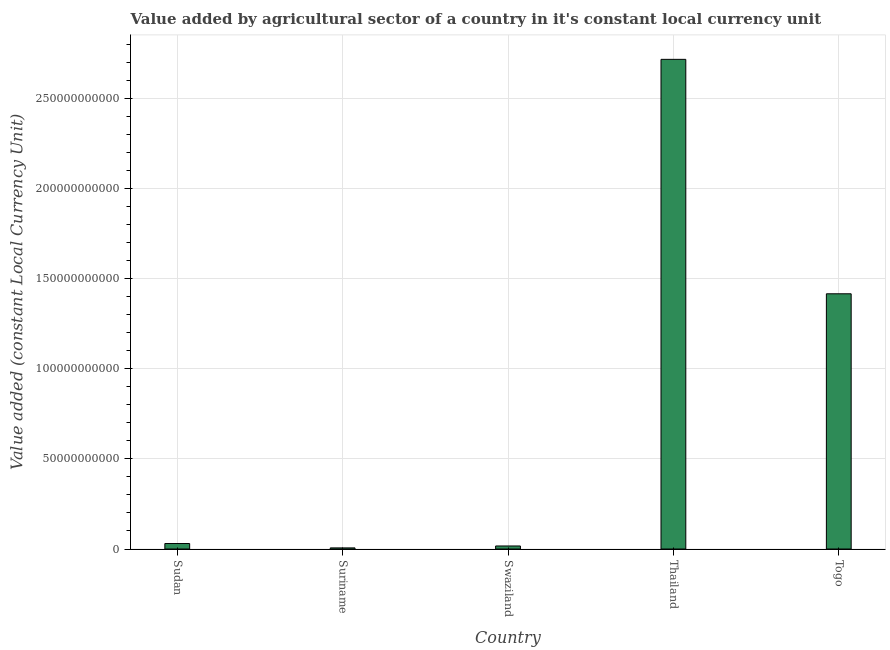Does the graph contain grids?
Give a very brief answer. Yes. What is the title of the graph?
Your answer should be compact. Value added by agricultural sector of a country in it's constant local currency unit. What is the label or title of the X-axis?
Give a very brief answer. Country. What is the label or title of the Y-axis?
Your response must be concise. Value added (constant Local Currency Unit). What is the value added by agriculture sector in Sudan?
Your response must be concise. 3.04e+09. Across all countries, what is the maximum value added by agriculture sector?
Your answer should be compact. 2.72e+11. Across all countries, what is the minimum value added by agriculture sector?
Your answer should be very brief. 6.15e+08. In which country was the value added by agriculture sector maximum?
Make the answer very short. Thailand. In which country was the value added by agriculture sector minimum?
Offer a very short reply. Suriname. What is the sum of the value added by agriculture sector?
Ensure brevity in your answer.  4.18e+11. What is the difference between the value added by agriculture sector in Suriname and Swaziland?
Your response must be concise. -1.07e+09. What is the average value added by agriculture sector per country?
Offer a terse response. 8.37e+1. What is the median value added by agriculture sector?
Offer a very short reply. 3.04e+09. What is the ratio of the value added by agriculture sector in Suriname to that in Togo?
Give a very brief answer. 0. Is the value added by agriculture sector in Sudan less than that in Togo?
Offer a terse response. Yes. What is the difference between the highest and the second highest value added by agriculture sector?
Provide a short and direct response. 1.30e+11. What is the difference between the highest and the lowest value added by agriculture sector?
Ensure brevity in your answer.  2.71e+11. In how many countries, is the value added by agriculture sector greater than the average value added by agriculture sector taken over all countries?
Offer a very short reply. 2. Are all the bars in the graph horizontal?
Your response must be concise. No. How many countries are there in the graph?
Offer a very short reply. 5. What is the difference between two consecutive major ticks on the Y-axis?
Your answer should be very brief. 5.00e+1. Are the values on the major ticks of Y-axis written in scientific E-notation?
Your answer should be compact. No. What is the Value added (constant Local Currency Unit) of Sudan?
Your answer should be very brief. 3.04e+09. What is the Value added (constant Local Currency Unit) in Suriname?
Provide a succinct answer. 6.15e+08. What is the Value added (constant Local Currency Unit) in Swaziland?
Offer a very short reply. 1.68e+09. What is the Value added (constant Local Currency Unit) in Thailand?
Your answer should be very brief. 2.72e+11. What is the Value added (constant Local Currency Unit) of Togo?
Give a very brief answer. 1.42e+11. What is the difference between the Value added (constant Local Currency Unit) in Sudan and Suriname?
Your response must be concise. 2.42e+09. What is the difference between the Value added (constant Local Currency Unit) in Sudan and Swaziland?
Make the answer very short. 1.36e+09. What is the difference between the Value added (constant Local Currency Unit) in Sudan and Thailand?
Your response must be concise. -2.69e+11. What is the difference between the Value added (constant Local Currency Unit) in Sudan and Togo?
Ensure brevity in your answer.  -1.39e+11. What is the difference between the Value added (constant Local Currency Unit) in Suriname and Swaziland?
Provide a succinct answer. -1.07e+09. What is the difference between the Value added (constant Local Currency Unit) in Suriname and Thailand?
Offer a terse response. -2.71e+11. What is the difference between the Value added (constant Local Currency Unit) in Suriname and Togo?
Keep it short and to the point. -1.41e+11. What is the difference between the Value added (constant Local Currency Unit) in Swaziland and Thailand?
Your answer should be very brief. -2.70e+11. What is the difference between the Value added (constant Local Currency Unit) in Swaziland and Togo?
Provide a short and direct response. -1.40e+11. What is the difference between the Value added (constant Local Currency Unit) in Thailand and Togo?
Keep it short and to the point. 1.30e+11. What is the ratio of the Value added (constant Local Currency Unit) in Sudan to that in Suriname?
Offer a very short reply. 4.94. What is the ratio of the Value added (constant Local Currency Unit) in Sudan to that in Swaziland?
Keep it short and to the point. 1.81. What is the ratio of the Value added (constant Local Currency Unit) in Sudan to that in Thailand?
Provide a short and direct response. 0.01. What is the ratio of the Value added (constant Local Currency Unit) in Sudan to that in Togo?
Your answer should be compact. 0.02. What is the ratio of the Value added (constant Local Currency Unit) in Suriname to that in Swaziland?
Provide a succinct answer. 0.36. What is the ratio of the Value added (constant Local Currency Unit) in Suriname to that in Thailand?
Your response must be concise. 0. What is the ratio of the Value added (constant Local Currency Unit) in Suriname to that in Togo?
Keep it short and to the point. 0. What is the ratio of the Value added (constant Local Currency Unit) in Swaziland to that in Thailand?
Your answer should be compact. 0.01. What is the ratio of the Value added (constant Local Currency Unit) in Swaziland to that in Togo?
Ensure brevity in your answer.  0.01. What is the ratio of the Value added (constant Local Currency Unit) in Thailand to that in Togo?
Ensure brevity in your answer.  1.92. 